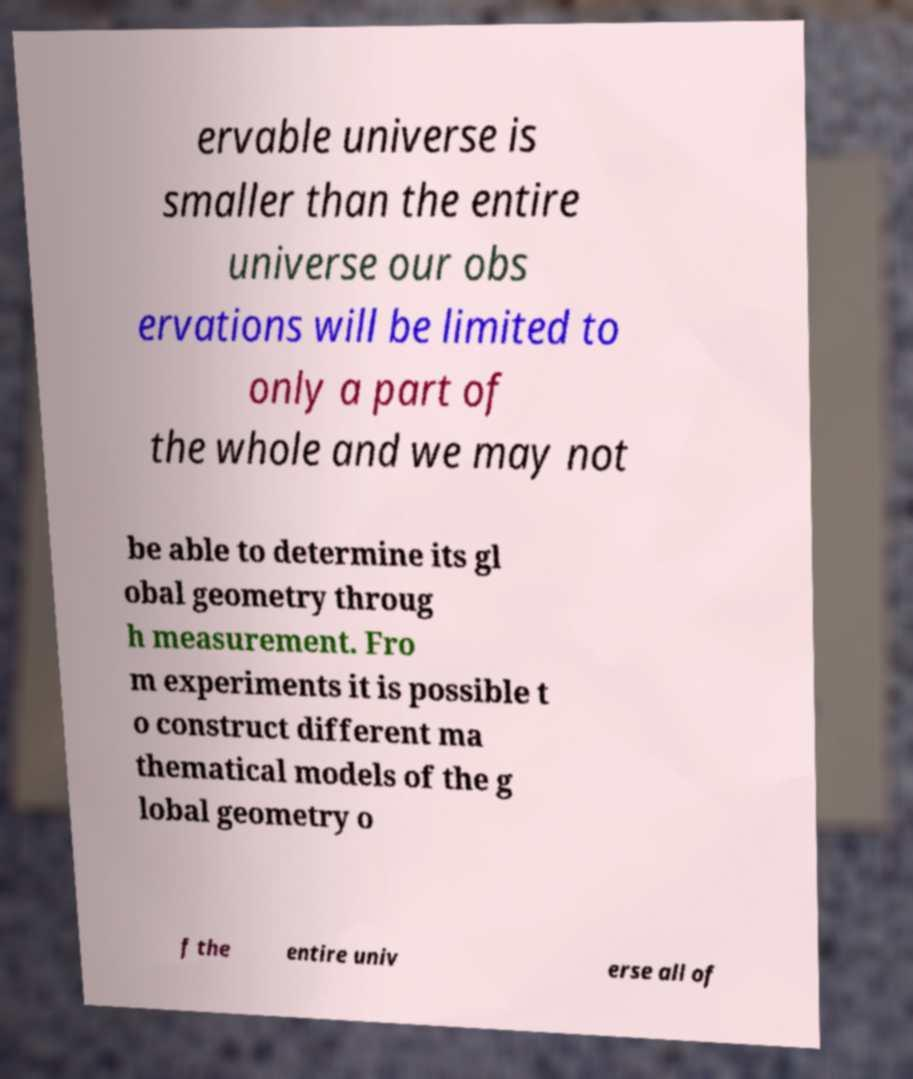What messages or text are displayed in this image? I need them in a readable, typed format. ervable universe is smaller than the entire universe our obs ervations will be limited to only a part of the whole and we may not be able to determine its gl obal geometry throug h measurement. Fro m experiments it is possible t o construct different ma thematical models of the g lobal geometry o f the entire univ erse all of 